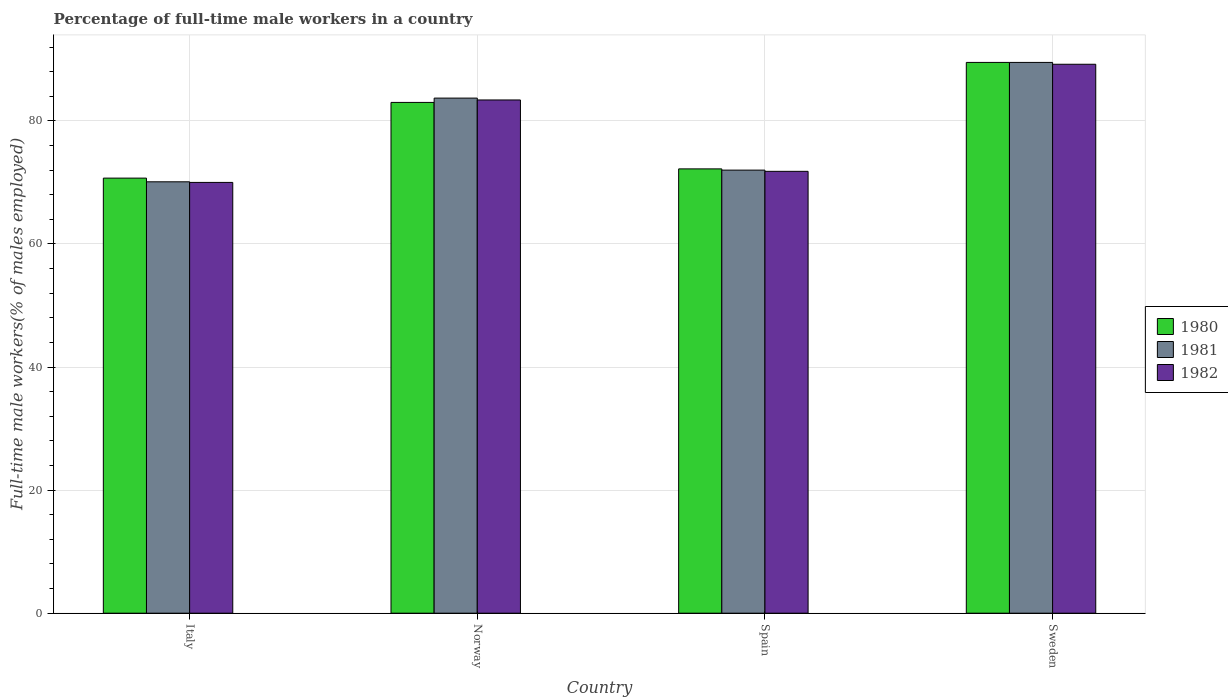Are the number of bars per tick equal to the number of legend labels?
Ensure brevity in your answer.  Yes. What is the label of the 2nd group of bars from the left?
Your answer should be compact. Norway. What is the percentage of full-time male workers in 1980 in Norway?
Your answer should be compact. 83. Across all countries, what is the maximum percentage of full-time male workers in 1980?
Make the answer very short. 89.5. Across all countries, what is the minimum percentage of full-time male workers in 1982?
Your response must be concise. 70. In which country was the percentage of full-time male workers in 1980 maximum?
Your answer should be compact. Sweden. What is the total percentage of full-time male workers in 1982 in the graph?
Give a very brief answer. 314.4. What is the difference between the percentage of full-time male workers in 1982 in Spain and the percentage of full-time male workers in 1981 in Italy?
Offer a very short reply. 1.7. What is the average percentage of full-time male workers in 1982 per country?
Your response must be concise. 78.6. What is the difference between the percentage of full-time male workers of/in 1980 and percentage of full-time male workers of/in 1982 in Sweden?
Make the answer very short. 0.3. What is the ratio of the percentage of full-time male workers in 1980 in Spain to that in Sweden?
Make the answer very short. 0.81. Is the difference between the percentage of full-time male workers in 1980 in Norway and Spain greater than the difference between the percentage of full-time male workers in 1982 in Norway and Spain?
Ensure brevity in your answer.  No. What is the difference between the highest and the second highest percentage of full-time male workers in 1980?
Keep it short and to the point. -17.3. What is the difference between the highest and the lowest percentage of full-time male workers in 1982?
Your answer should be compact. 19.2. In how many countries, is the percentage of full-time male workers in 1980 greater than the average percentage of full-time male workers in 1980 taken over all countries?
Give a very brief answer. 2. Is the sum of the percentage of full-time male workers in 1982 in Spain and Sweden greater than the maximum percentage of full-time male workers in 1980 across all countries?
Provide a short and direct response. Yes. What does the 2nd bar from the left in Italy represents?
Your answer should be compact. 1981. What does the 3rd bar from the right in Sweden represents?
Give a very brief answer. 1980. Is it the case that in every country, the sum of the percentage of full-time male workers in 1980 and percentage of full-time male workers in 1982 is greater than the percentage of full-time male workers in 1981?
Your answer should be very brief. Yes. Are all the bars in the graph horizontal?
Keep it short and to the point. No. Are the values on the major ticks of Y-axis written in scientific E-notation?
Provide a succinct answer. No. Where does the legend appear in the graph?
Ensure brevity in your answer.  Center right. What is the title of the graph?
Your response must be concise. Percentage of full-time male workers in a country. What is the label or title of the Y-axis?
Ensure brevity in your answer.  Full-time male workers(% of males employed). What is the Full-time male workers(% of males employed) of 1980 in Italy?
Ensure brevity in your answer.  70.7. What is the Full-time male workers(% of males employed) of 1981 in Italy?
Your answer should be very brief. 70.1. What is the Full-time male workers(% of males employed) in 1981 in Norway?
Offer a very short reply. 83.7. What is the Full-time male workers(% of males employed) of 1982 in Norway?
Offer a very short reply. 83.4. What is the Full-time male workers(% of males employed) of 1980 in Spain?
Give a very brief answer. 72.2. What is the Full-time male workers(% of males employed) of 1982 in Spain?
Provide a short and direct response. 71.8. What is the Full-time male workers(% of males employed) in 1980 in Sweden?
Your response must be concise. 89.5. What is the Full-time male workers(% of males employed) of 1981 in Sweden?
Keep it short and to the point. 89.5. What is the Full-time male workers(% of males employed) in 1982 in Sweden?
Make the answer very short. 89.2. Across all countries, what is the maximum Full-time male workers(% of males employed) in 1980?
Keep it short and to the point. 89.5. Across all countries, what is the maximum Full-time male workers(% of males employed) of 1981?
Your response must be concise. 89.5. Across all countries, what is the maximum Full-time male workers(% of males employed) of 1982?
Offer a very short reply. 89.2. Across all countries, what is the minimum Full-time male workers(% of males employed) in 1980?
Your answer should be compact. 70.7. Across all countries, what is the minimum Full-time male workers(% of males employed) in 1981?
Your answer should be compact. 70.1. What is the total Full-time male workers(% of males employed) of 1980 in the graph?
Your answer should be compact. 315.4. What is the total Full-time male workers(% of males employed) of 1981 in the graph?
Your response must be concise. 315.3. What is the total Full-time male workers(% of males employed) in 1982 in the graph?
Offer a very short reply. 314.4. What is the difference between the Full-time male workers(% of males employed) in 1980 in Italy and that in Norway?
Provide a short and direct response. -12.3. What is the difference between the Full-time male workers(% of males employed) of 1980 in Italy and that in Spain?
Your response must be concise. -1.5. What is the difference between the Full-time male workers(% of males employed) of 1982 in Italy and that in Spain?
Provide a short and direct response. -1.8. What is the difference between the Full-time male workers(% of males employed) of 1980 in Italy and that in Sweden?
Keep it short and to the point. -18.8. What is the difference between the Full-time male workers(% of males employed) in 1981 in Italy and that in Sweden?
Offer a terse response. -19.4. What is the difference between the Full-time male workers(% of males employed) of 1982 in Italy and that in Sweden?
Keep it short and to the point. -19.2. What is the difference between the Full-time male workers(% of males employed) in 1980 in Norway and that in Spain?
Make the answer very short. 10.8. What is the difference between the Full-time male workers(% of males employed) of 1982 in Norway and that in Spain?
Give a very brief answer. 11.6. What is the difference between the Full-time male workers(% of males employed) of 1980 in Spain and that in Sweden?
Your answer should be very brief. -17.3. What is the difference between the Full-time male workers(% of males employed) of 1981 in Spain and that in Sweden?
Your answer should be compact. -17.5. What is the difference between the Full-time male workers(% of males employed) in 1982 in Spain and that in Sweden?
Your answer should be very brief. -17.4. What is the difference between the Full-time male workers(% of males employed) in 1980 in Italy and the Full-time male workers(% of males employed) in 1982 in Norway?
Provide a succinct answer. -12.7. What is the difference between the Full-time male workers(% of males employed) in 1980 in Italy and the Full-time male workers(% of males employed) in 1981 in Spain?
Make the answer very short. -1.3. What is the difference between the Full-time male workers(% of males employed) of 1981 in Italy and the Full-time male workers(% of males employed) of 1982 in Spain?
Make the answer very short. -1.7. What is the difference between the Full-time male workers(% of males employed) of 1980 in Italy and the Full-time male workers(% of males employed) of 1981 in Sweden?
Your response must be concise. -18.8. What is the difference between the Full-time male workers(% of males employed) in 1980 in Italy and the Full-time male workers(% of males employed) in 1982 in Sweden?
Keep it short and to the point. -18.5. What is the difference between the Full-time male workers(% of males employed) of 1981 in Italy and the Full-time male workers(% of males employed) of 1982 in Sweden?
Offer a very short reply. -19.1. What is the difference between the Full-time male workers(% of males employed) of 1980 in Norway and the Full-time male workers(% of males employed) of 1982 in Spain?
Offer a terse response. 11.2. What is the difference between the Full-time male workers(% of males employed) in 1980 in Norway and the Full-time male workers(% of males employed) in 1981 in Sweden?
Offer a very short reply. -6.5. What is the difference between the Full-time male workers(% of males employed) of 1981 in Norway and the Full-time male workers(% of males employed) of 1982 in Sweden?
Your response must be concise. -5.5. What is the difference between the Full-time male workers(% of males employed) of 1980 in Spain and the Full-time male workers(% of males employed) of 1981 in Sweden?
Your answer should be very brief. -17.3. What is the difference between the Full-time male workers(% of males employed) of 1980 in Spain and the Full-time male workers(% of males employed) of 1982 in Sweden?
Give a very brief answer. -17. What is the difference between the Full-time male workers(% of males employed) in 1981 in Spain and the Full-time male workers(% of males employed) in 1982 in Sweden?
Offer a terse response. -17.2. What is the average Full-time male workers(% of males employed) of 1980 per country?
Your answer should be very brief. 78.85. What is the average Full-time male workers(% of males employed) of 1981 per country?
Offer a very short reply. 78.83. What is the average Full-time male workers(% of males employed) of 1982 per country?
Provide a short and direct response. 78.6. What is the difference between the Full-time male workers(% of males employed) in 1980 and Full-time male workers(% of males employed) in 1982 in Italy?
Provide a short and direct response. 0.7. What is the difference between the Full-time male workers(% of males employed) in 1981 and Full-time male workers(% of males employed) in 1982 in Italy?
Your response must be concise. 0.1. What is the difference between the Full-time male workers(% of males employed) in 1980 and Full-time male workers(% of males employed) in 1982 in Norway?
Your answer should be compact. -0.4. What is the difference between the Full-time male workers(% of males employed) of 1981 and Full-time male workers(% of males employed) of 1982 in Norway?
Your answer should be very brief. 0.3. What is the difference between the Full-time male workers(% of males employed) of 1980 and Full-time male workers(% of males employed) of 1982 in Spain?
Ensure brevity in your answer.  0.4. What is the difference between the Full-time male workers(% of males employed) in 1981 and Full-time male workers(% of males employed) in 1982 in Spain?
Provide a succinct answer. 0.2. What is the difference between the Full-time male workers(% of males employed) of 1980 and Full-time male workers(% of males employed) of 1981 in Sweden?
Give a very brief answer. 0. What is the ratio of the Full-time male workers(% of males employed) of 1980 in Italy to that in Norway?
Provide a succinct answer. 0.85. What is the ratio of the Full-time male workers(% of males employed) of 1981 in Italy to that in Norway?
Offer a terse response. 0.84. What is the ratio of the Full-time male workers(% of males employed) of 1982 in Italy to that in Norway?
Offer a very short reply. 0.84. What is the ratio of the Full-time male workers(% of males employed) of 1980 in Italy to that in Spain?
Offer a terse response. 0.98. What is the ratio of the Full-time male workers(% of males employed) of 1981 in Italy to that in Spain?
Ensure brevity in your answer.  0.97. What is the ratio of the Full-time male workers(% of males employed) of 1982 in Italy to that in Spain?
Keep it short and to the point. 0.97. What is the ratio of the Full-time male workers(% of males employed) in 1980 in Italy to that in Sweden?
Give a very brief answer. 0.79. What is the ratio of the Full-time male workers(% of males employed) of 1981 in Italy to that in Sweden?
Ensure brevity in your answer.  0.78. What is the ratio of the Full-time male workers(% of males employed) of 1982 in Italy to that in Sweden?
Your answer should be very brief. 0.78. What is the ratio of the Full-time male workers(% of males employed) in 1980 in Norway to that in Spain?
Ensure brevity in your answer.  1.15. What is the ratio of the Full-time male workers(% of males employed) in 1981 in Norway to that in Spain?
Provide a succinct answer. 1.16. What is the ratio of the Full-time male workers(% of males employed) of 1982 in Norway to that in Spain?
Provide a short and direct response. 1.16. What is the ratio of the Full-time male workers(% of males employed) in 1980 in Norway to that in Sweden?
Give a very brief answer. 0.93. What is the ratio of the Full-time male workers(% of males employed) of 1981 in Norway to that in Sweden?
Give a very brief answer. 0.94. What is the ratio of the Full-time male workers(% of males employed) of 1982 in Norway to that in Sweden?
Offer a terse response. 0.94. What is the ratio of the Full-time male workers(% of males employed) of 1980 in Spain to that in Sweden?
Offer a terse response. 0.81. What is the ratio of the Full-time male workers(% of males employed) in 1981 in Spain to that in Sweden?
Keep it short and to the point. 0.8. What is the ratio of the Full-time male workers(% of males employed) of 1982 in Spain to that in Sweden?
Offer a very short reply. 0.8. What is the difference between the highest and the second highest Full-time male workers(% of males employed) of 1980?
Offer a terse response. 6.5. What is the difference between the highest and the second highest Full-time male workers(% of males employed) in 1981?
Keep it short and to the point. 5.8. What is the difference between the highest and the second highest Full-time male workers(% of males employed) in 1982?
Offer a terse response. 5.8. What is the difference between the highest and the lowest Full-time male workers(% of males employed) in 1980?
Provide a succinct answer. 18.8. What is the difference between the highest and the lowest Full-time male workers(% of males employed) of 1981?
Your answer should be compact. 19.4. 